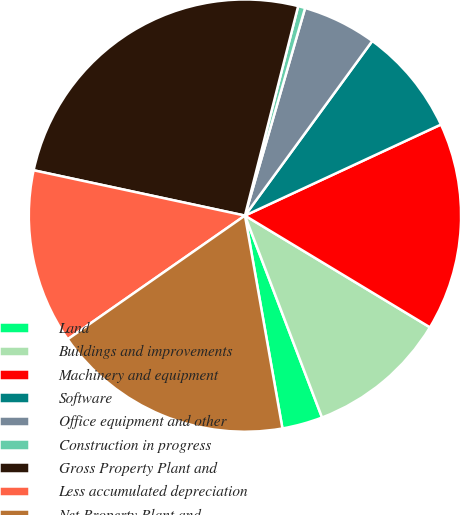Convert chart to OTSL. <chart><loc_0><loc_0><loc_500><loc_500><pie_chart><fcel>Land<fcel>Buildings and improvements<fcel>Machinery and equipment<fcel>Software<fcel>Office equipment and other<fcel>Construction in progress<fcel>Gross Property Plant and<fcel>Less accumulated depreciation<fcel>Net Property Plant and<nl><fcel>3.03%<fcel>10.55%<fcel>15.57%<fcel>8.05%<fcel>5.54%<fcel>0.53%<fcel>25.6%<fcel>13.06%<fcel>18.08%<nl></chart> 